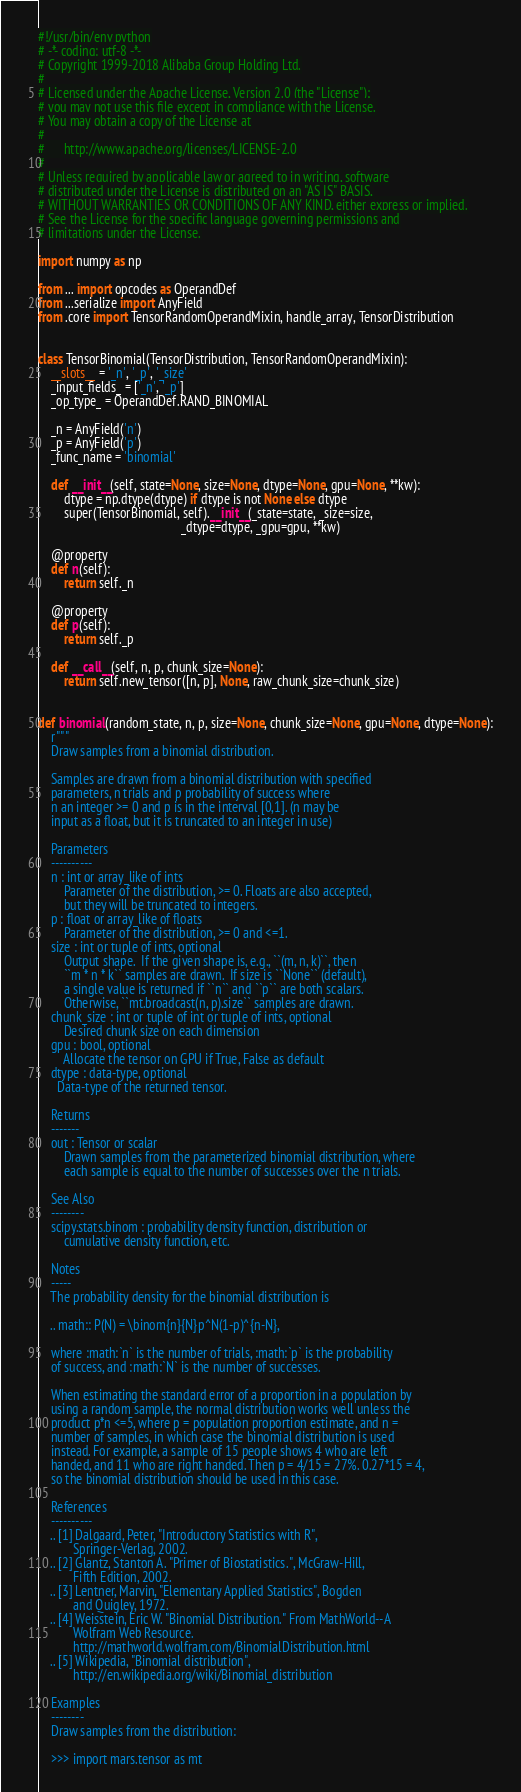Convert code to text. <code><loc_0><loc_0><loc_500><loc_500><_Python_>#!/usr/bin/env python
# -*- coding: utf-8 -*-
# Copyright 1999-2018 Alibaba Group Holding Ltd.
#
# Licensed under the Apache License, Version 2.0 (the "License");
# you may not use this file except in compliance with the License.
# You may obtain a copy of the License at
#
#      http://www.apache.org/licenses/LICENSE-2.0
#
# Unless required by applicable law or agreed to in writing, software
# distributed under the License is distributed on an "AS IS" BASIS,
# WITHOUT WARRANTIES OR CONDITIONS OF ANY KIND, either express or implied.
# See the License for the specific language governing permissions and
# limitations under the License.

import numpy as np

from ... import opcodes as OperandDef
from ...serialize import AnyField
from .core import TensorRandomOperandMixin, handle_array, TensorDistribution


class TensorBinomial(TensorDistribution, TensorRandomOperandMixin):
    __slots__ = '_n', '_p', '_size'
    _input_fields_ = ['_n', '_p']
    _op_type_ = OperandDef.RAND_BINOMIAL

    _n = AnyField('n')
    _p = AnyField('p')
    _func_name = 'binomial'

    def __init__(self, state=None, size=None, dtype=None, gpu=None, **kw):
        dtype = np.dtype(dtype) if dtype is not None else dtype
        super(TensorBinomial, self).__init__(_state=state, _size=size,
                                             _dtype=dtype, _gpu=gpu, **kw)

    @property
    def n(self):
        return self._n

    @property
    def p(self):
        return self._p

    def __call__(self, n, p, chunk_size=None):
        return self.new_tensor([n, p], None, raw_chunk_size=chunk_size)


def binomial(random_state, n, p, size=None, chunk_size=None, gpu=None, dtype=None):
    r"""
    Draw samples from a binomial distribution.

    Samples are drawn from a binomial distribution with specified
    parameters, n trials and p probability of success where
    n an integer >= 0 and p is in the interval [0,1]. (n may be
    input as a float, but it is truncated to an integer in use)

    Parameters
    ----------
    n : int or array_like of ints
        Parameter of the distribution, >= 0. Floats are also accepted,
        but they will be truncated to integers.
    p : float or array_like of floats
        Parameter of the distribution, >= 0 and <=1.
    size : int or tuple of ints, optional
        Output shape.  If the given shape is, e.g., ``(m, n, k)``, then
        ``m * n * k`` samples are drawn.  If size is ``None`` (default),
        a single value is returned if ``n`` and ``p`` are both scalars.
        Otherwise, ``mt.broadcast(n, p).size`` samples are drawn.
    chunk_size : int or tuple of int or tuple of ints, optional
        Desired chunk size on each dimension
    gpu : bool, optional
        Allocate the tensor on GPU if True, False as default
    dtype : data-type, optional
      Data-type of the returned tensor.

    Returns
    -------
    out : Tensor or scalar
        Drawn samples from the parameterized binomial distribution, where
        each sample is equal to the number of successes over the n trials.

    See Also
    --------
    scipy.stats.binom : probability density function, distribution or
        cumulative density function, etc.

    Notes
    -----
    The probability density for the binomial distribution is

    .. math:: P(N) = \binom{n}{N}p^N(1-p)^{n-N},

    where :math:`n` is the number of trials, :math:`p` is the probability
    of success, and :math:`N` is the number of successes.

    When estimating the standard error of a proportion in a population by
    using a random sample, the normal distribution works well unless the
    product p*n <=5, where p = population proportion estimate, and n =
    number of samples, in which case the binomial distribution is used
    instead. For example, a sample of 15 people shows 4 who are left
    handed, and 11 who are right handed. Then p = 4/15 = 27%. 0.27*15 = 4,
    so the binomial distribution should be used in this case.

    References
    ----------
    .. [1] Dalgaard, Peter, "Introductory Statistics with R",
           Springer-Verlag, 2002.
    .. [2] Glantz, Stanton A. "Primer of Biostatistics.", McGraw-Hill,
           Fifth Edition, 2002.
    .. [3] Lentner, Marvin, "Elementary Applied Statistics", Bogden
           and Quigley, 1972.
    .. [4] Weisstein, Eric W. "Binomial Distribution." From MathWorld--A
           Wolfram Web Resource.
           http://mathworld.wolfram.com/BinomialDistribution.html
    .. [5] Wikipedia, "Binomial distribution",
           http://en.wikipedia.org/wiki/Binomial_distribution

    Examples
    --------
    Draw samples from the distribution:

    >>> import mars.tensor as mt
</code> 